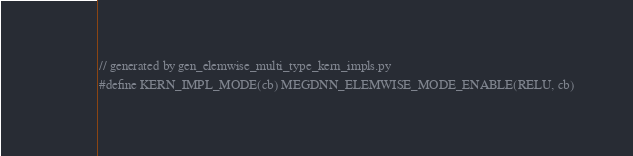<code> <loc_0><loc_0><loc_500><loc_500><_Cuda_>// generated by gen_elemwise_multi_type_kern_impls.py
#define KERN_IMPL_MODE(cb) MEGDNN_ELEMWISE_MODE_ENABLE(RELU, cb)</code> 